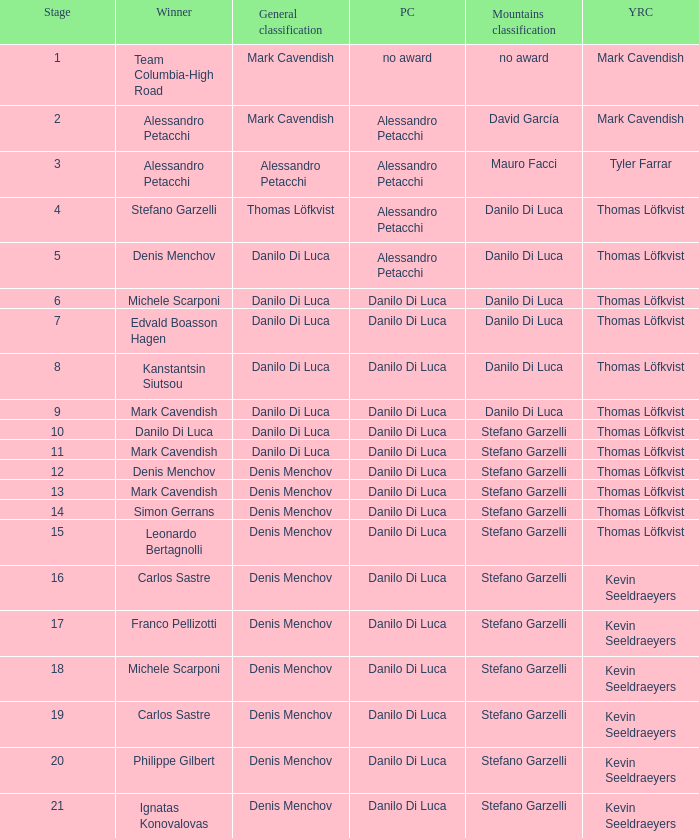When thomas löfkvist is the  young rider classification and alessandro petacchi is the points classification who are the general classifications?  Thomas Löfkvist, Danilo Di Luca. 